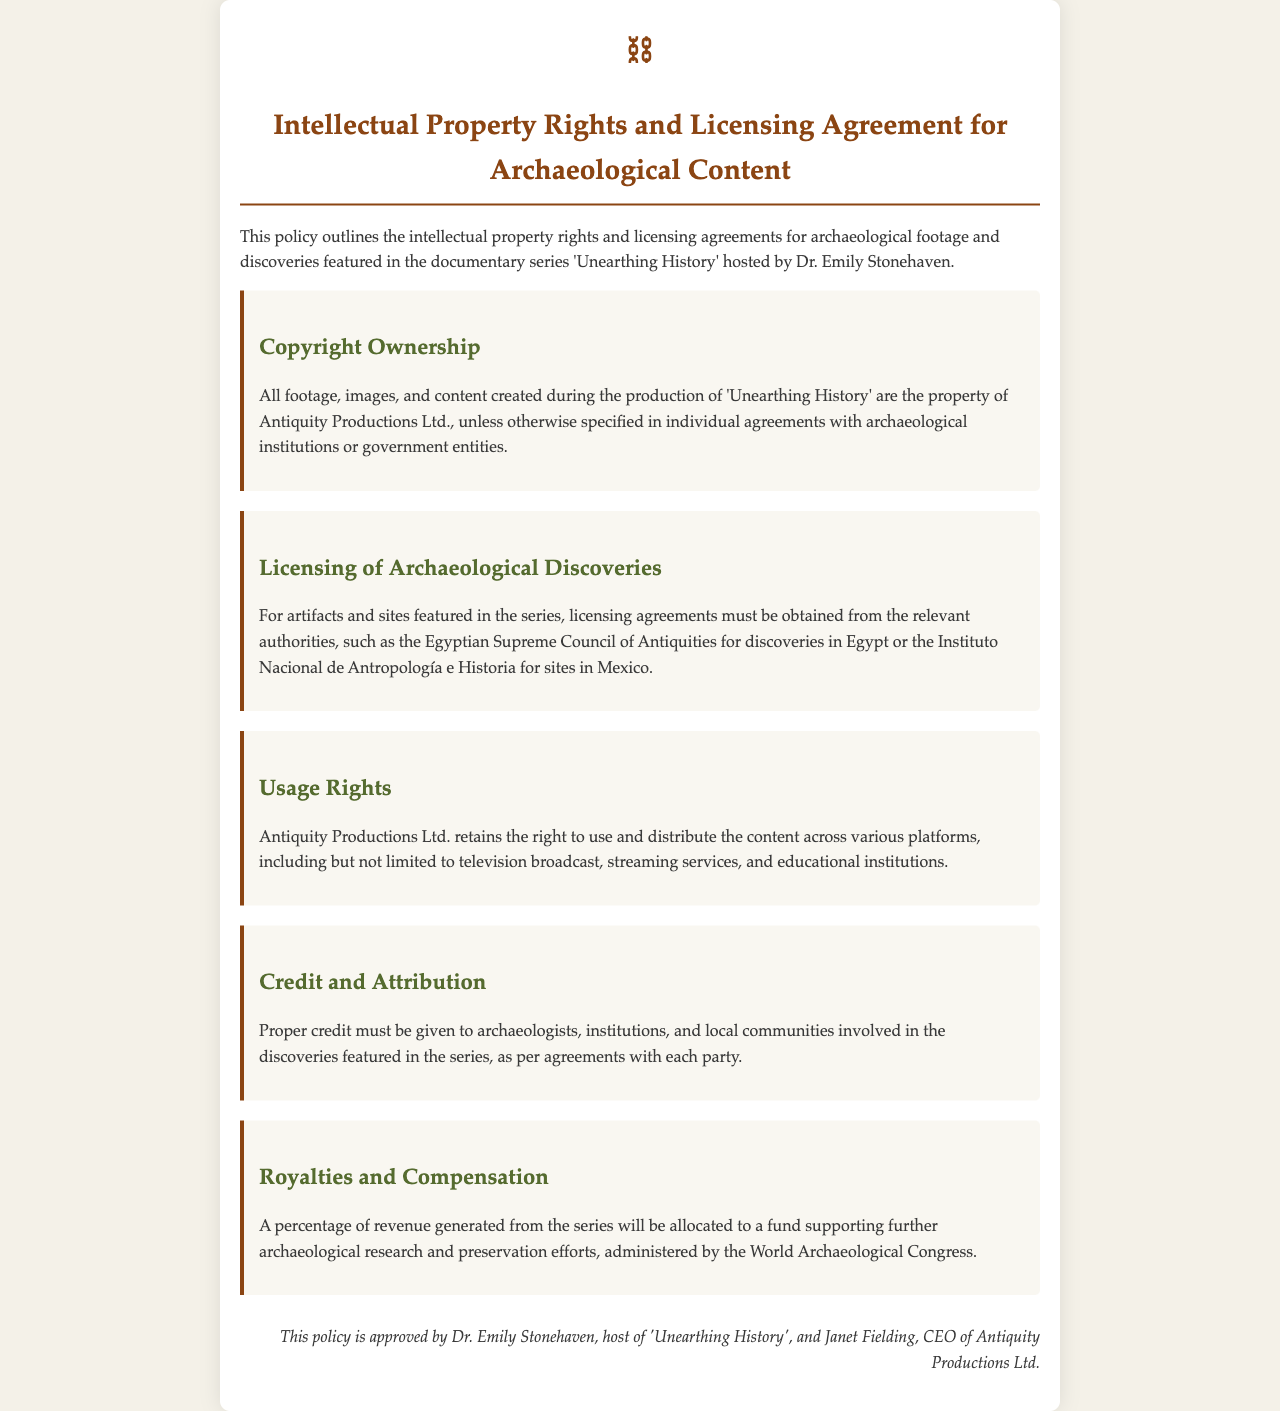What is the title of the document? The title is prominently displayed at the top of the document as the main heading.
Answer: Intellectual Property Rights and Licensing Agreement for Archaeological Content Who owns the copyright of the footage? The document states the ownership of copyright in the section about Copyright Ownership.
Answer: Antiquity Productions Ltd What must be obtained for artifacts featured in the series? The section on Licensing of Archaeological Discoveries specifies this requirement.
Answer: Licensing agreements Which organization administers the fund for archaeological research? The document mentions the administration of the fund in the Royalties and Compensation section.
Answer: World Archaeological Congress What must be given to archaeologists and institutions involved? This is explained in the Credit and Attribution section of the document.
Answer: Proper credit Which specific council needs licensing agreements for discoveries in Egypt? The Licensing of Archaeological Discoveries section provides details on this specific authority.
Answer: Egyptian Supreme Council of Antiquities Who are the approvers of this policy? The signature section identifies the people who approved the policy.
Answer: Dr. Emily Stonehaven and Janet Fielding 